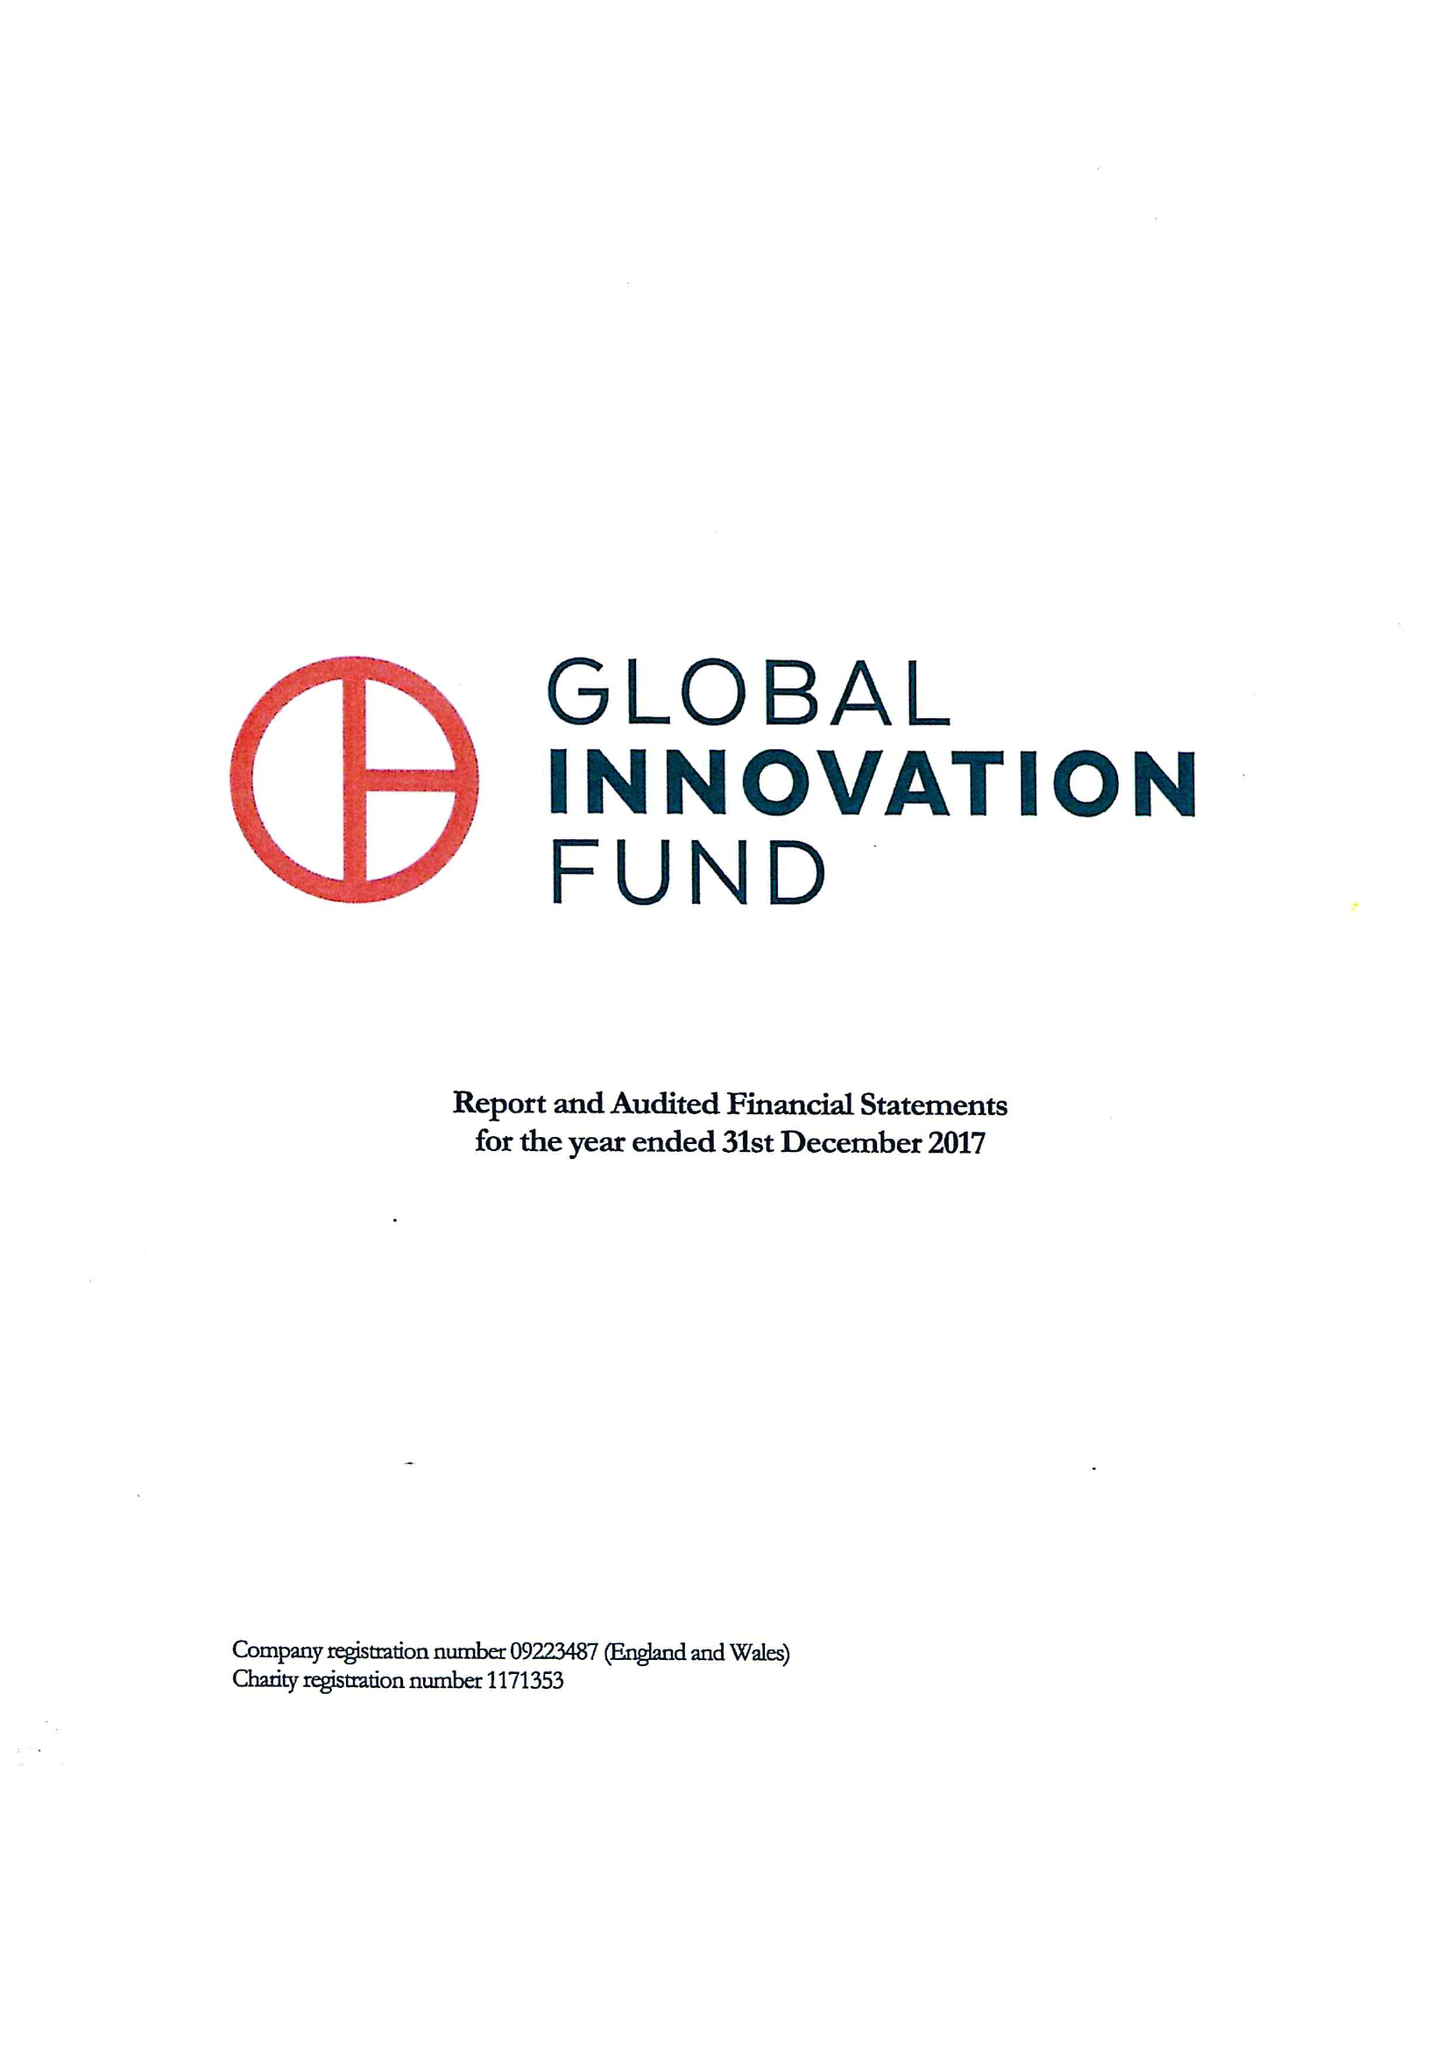What is the value for the income_annually_in_british_pounds?
Answer the question using a single word or phrase. 21268000.00 